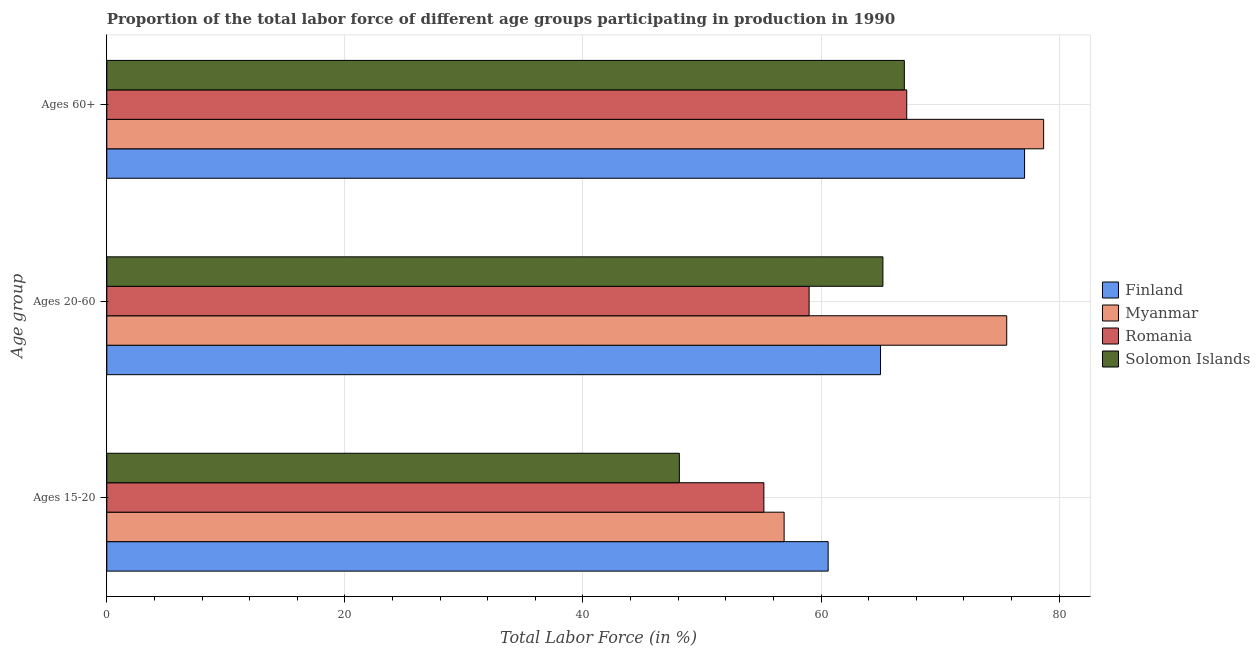How many different coloured bars are there?
Make the answer very short. 4. Are the number of bars on each tick of the Y-axis equal?
Offer a terse response. Yes. What is the label of the 3rd group of bars from the top?
Your response must be concise. Ages 15-20. What is the percentage of labor force within the age group 20-60 in Myanmar?
Provide a short and direct response. 75.6. Across all countries, what is the maximum percentage of labor force above age 60?
Ensure brevity in your answer.  78.7. Across all countries, what is the minimum percentage of labor force within the age group 15-20?
Your answer should be very brief. 48.1. In which country was the percentage of labor force within the age group 20-60 maximum?
Offer a very short reply. Myanmar. In which country was the percentage of labor force above age 60 minimum?
Provide a short and direct response. Solomon Islands. What is the total percentage of labor force within the age group 20-60 in the graph?
Keep it short and to the point. 264.8. What is the difference between the percentage of labor force within the age group 15-20 in Romania and that in Finland?
Your response must be concise. -5.4. What is the difference between the percentage of labor force within the age group 15-20 in Romania and the percentage of labor force within the age group 20-60 in Solomon Islands?
Your response must be concise. -10. What is the average percentage of labor force within the age group 20-60 per country?
Your answer should be compact. 66.2. What is the difference between the percentage of labor force above age 60 and percentage of labor force within the age group 15-20 in Finland?
Ensure brevity in your answer.  16.5. In how many countries, is the percentage of labor force within the age group 20-60 greater than 16 %?
Provide a short and direct response. 4. What is the ratio of the percentage of labor force within the age group 15-20 in Finland to that in Romania?
Make the answer very short. 1.1. Is the percentage of labor force above age 60 in Myanmar less than that in Solomon Islands?
Offer a terse response. No. What is the difference between the highest and the second highest percentage of labor force above age 60?
Provide a short and direct response. 1.6. What is the difference between the highest and the lowest percentage of labor force within the age group 20-60?
Give a very brief answer. 16.6. In how many countries, is the percentage of labor force above age 60 greater than the average percentage of labor force above age 60 taken over all countries?
Provide a short and direct response. 2. What does the 3rd bar from the top in Ages 20-60 represents?
Provide a succinct answer. Myanmar. What does the 2nd bar from the bottom in Ages 20-60 represents?
Your answer should be very brief. Myanmar. How many bars are there?
Ensure brevity in your answer.  12. Are the values on the major ticks of X-axis written in scientific E-notation?
Offer a terse response. No. Does the graph contain grids?
Your answer should be very brief. Yes. Where does the legend appear in the graph?
Keep it short and to the point. Center right. What is the title of the graph?
Your answer should be compact. Proportion of the total labor force of different age groups participating in production in 1990. Does "OECD members" appear as one of the legend labels in the graph?
Keep it short and to the point. No. What is the label or title of the X-axis?
Your response must be concise. Total Labor Force (in %). What is the label or title of the Y-axis?
Your response must be concise. Age group. What is the Total Labor Force (in %) of Finland in Ages 15-20?
Offer a very short reply. 60.6. What is the Total Labor Force (in %) in Myanmar in Ages 15-20?
Your response must be concise. 56.9. What is the Total Labor Force (in %) of Romania in Ages 15-20?
Ensure brevity in your answer.  55.2. What is the Total Labor Force (in %) of Solomon Islands in Ages 15-20?
Your answer should be very brief. 48.1. What is the Total Labor Force (in %) in Finland in Ages 20-60?
Your response must be concise. 65. What is the Total Labor Force (in %) in Myanmar in Ages 20-60?
Ensure brevity in your answer.  75.6. What is the Total Labor Force (in %) of Solomon Islands in Ages 20-60?
Your response must be concise. 65.2. What is the Total Labor Force (in %) of Finland in Ages 60+?
Keep it short and to the point. 77.1. What is the Total Labor Force (in %) in Myanmar in Ages 60+?
Keep it short and to the point. 78.7. What is the Total Labor Force (in %) in Romania in Ages 60+?
Provide a succinct answer. 67.2. Across all Age group, what is the maximum Total Labor Force (in %) in Finland?
Your answer should be very brief. 77.1. Across all Age group, what is the maximum Total Labor Force (in %) of Myanmar?
Offer a terse response. 78.7. Across all Age group, what is the maximum Total Labor Force (in %) in Romania?
Give a very brief answer. 67.2. Across all Age group, what is the minimum Total Labor Force (in %) in Finland?
Your answer should be very brief. 60.6. Across all Age group, what is the minimum Total Labor Force (in %) in Myanmar?
Provide a succinct answer. 56.9. Across all Age group, what is the minimum Total Labor Force (in %) of Romania?
Give a very brief answer. 55.2. Across all Age group, what is the minimum Total Labor Force (in %) in Solomon Islands?
Ensure brevity in your answer.  48.1. What is the total Total Labor Force (in %) of Finland in the graph?
Your answer should be compact. 202.7. What is the total Total Labor Force (in %) of Myanmar in the graph?
Offer a terse response. 211.2. What is the total Total Labor Force (in %) in Romania in the graph?
Ensure brevity in your answer.  181.4. What is the total Total Labor Force (in %) of Solomon Islands in the graph?
Your response must be concise. 180.3. What is the difference between the Total Labor Force (in %) in Finland in Ages 15-20 and that in Ages 20-60?
Your answer should be very brief. -4.4. What is the difference between the Total Labor Force (in %) in Myanmar in Ages 15-20 and that in Ages 20-60?
Keep it short and to the point. -18.7. What is the difference between the Total Labor Force (in %) of Romania in Ages 15-20 and that in Ages 20-60?
Ensure brevity in your answer.  -3.8. What is the difference between the Total Labor Force (in %) of Solomon Islands in Ages 15-20 and that in Ages 20-60?
Provide a short and direct response. -17.1. What is the difference between the Total Labor Force (in %) in Finland in Ages 15-20 and that in Ages 60+?
Ensure brevity in your answer.  -16.5. What is the difference between the Total Labor Force (in %) in Myanmar in Ages 15-20 and that in Ages 60+?
Ensure brevity in your answer.  -21.8. What is the difference between the Total Labor Force (in %) in Solomon Islands in Ages 15-20 and that in Ages 60+?
Keep it short and to the point. -18.9. What is the difference between the Total Labor Force (in %) of Myanmar in Ages 20-60 and that in Ages 60+?
Make the answer very short. -3.1. What is the difference between the Total Labor Force (in %) in Romania in Ages 20-60 and that in Ages 60+?
Give a very brief answer. -8.2. What is the difference between the Total Labor Force (in %) of Finland in Ages 15-20 and the Total Labor Force (in %) of Myanmar in Ages 20-60?
Your response must be concise. -15. What is the difference between the Total Labor Force (in %) in Finland in Ages 15-20 and the Total Labor Force (in %) in Solomon Islands in Ages 20-60?
Your answer should be very brief. -4.6. What is the difference between the Total Labor Force (in %) of Myanmar in Ages 15-20 and the Total Labor Force (in %) of Romania in Ages 20-60?
Your answer should be compact. -2.1. What is the difference between the Total Labor Force (in %) of Myanmar in Ages 15-20 and the Total Labor Force (in %) of Solomon Islands in Ages 20-60?
Provide a short and direct response. -8.3. What is the difference between the Total Labor Force (in %) in Finland in Ages 15-20 and the Total Labor Force (in %) in Myanmar in Ages 60+?
Make the answer very short. -18.1. What is the difference between the Total Labor Force (in %) of Finland in Ages 15-20 and the Total Labor Force (in %) of Romania in Ages 60+?
Provide a succinct answer. -6.6. What is the difference between the Total Labor Force (in %) in Myanmar in Ages 15-20 and the Total Labor Force (in %) in Solomon Islands in Ages 60+?
Offer a terse response. -10.1. What is the difference between the Total Labor Force (in %) of Romania in Ages 15-20 and the Total Labor Force (in %) of Solomon Islands in Ages 60+?
Provide a short and direct response. -11.8. What is the difference between the Total Labor Force (in %) in Finland in Ages 20-60 and the Total Labor Force (in %) in Myanmar in Ages 60+?
Ensure brevity in your answer.  -13.7. What is the difference between the Total Labor Force (in %) of Finland in Ages 20-60 and the Total Labor Force (in %) of Romania in Ages 60+?
Your response must be concise. -2.2. What is the difference between the Total Labor Force (in %) of Finland in Ages 20-60 and the Total Labor Force (in %) of Solomon Islands in Ages 60+?
Offer a terse response. -2. What is the average Total Labor Force (in %) of Finland per Age group?
Offer a terse response. 67.57. What is the average Total Labor Force (in %) in Myanmar per Age group?
Your answer should be very brief. 70.4. What is the average Total Labor Force (in %) in Romania per Age group?
Give a very brief answer. 60.47. What is the average Total Labor Force (in %) of Solomon Islands per Age group?
Offer a very short reply. 60.1. What is the difference between the Total Labor Force (in %) in Finland and Total Labor Force (in %) in Romania in Ages 15-20?
Make the answer very short. 5.4. What is the difference between the Total Labor Force (in %) of Finland and Total Labor Force (in %) of Solomon Islands in Ages 15-20?
Provide a succinct answer. 12.5. What is the difference between the Total Labor Force (in %) of Myanmar and Total Labor Force (in %) of Romania in Ages 15-20?
Give a very brief answer. 1.7. What is the difference between the Total Labor Force (in %) in Finland and Total Labor Force (in %) in Myanmar in Ages 20-60?
Provide a succinct answer. -10.6. What is the difference between the Total Labor Force (in %) in Finland and Total Labor Force (in %) in Solomon Islands in Ages 20-60?
Ensure brevity in your answer.  -0.2. What is the difference between the Total Labor Force (in %) of Finland and Total Labor Force (in %) of Myanmar in Ages 60+?
Give a very brief answer. -1.6. What is the difference between the Total Labor Force (in %) in Finland and Total Labor Force (in %) in Romania in Ages 60+?
Your answer should be very brief. 9.9. What is the difference between the Total Labor Force (in %) of Finland and Total Labor Force (in %) of Solomon Islands in Ages 60+?
Give a very brief answer. 10.1. What is the difference between the Total Labor Force (in %) in Myanmar and Total Labor Force (in %) in Romania in Ages 60+?
Your answer should be very brief. 11.5. What is the difference between the Total Labor Force (in %) in Myanmar and Total Labor Force (in %) in Solomon Islands in Ages 60+?
Ensure brevity in your answer.  11.7. What is the difference between the Total Labor Force (in %) of Romania and Total Labor Force (in %) of Solomon Islands in Ages 60+?
Make the answer very short. 0.2. What is the ratio of the Total Labor Force (in %) of Finland in Ages 15-20 to that in Ages 20-60?
Make the answer very short. 0.93. What is the ratio of the Total Labor Force (in %) in Myanmar in Ages 15-20 to that in Ages 20-60?
Offer a terse response. 0.75. What is the ratio of the Total Labor Force (in %) in Romania in Ages 15-20 to that in Ages 20-60?
Your answer should be very brief. 0.94. What is the ratio of the Total Labor Force (in %) in Solomon Islands in Ages 15-20 to that in Ages 20-60?
Your answer should be very brief. 0.74. What is the ratio of the Total Labor Force (in %) of Finland in Ages 15-20 to that in Ages 60+?
Make the answer very short. 0.79. What is the ratio of the Total Labor Force (in %) in Myanmar in Ages 15-20 to that in Ages 60+?
Provide a short and direct response. 0.72. What is the ratio of the Total Labor Force (in %) of Romania in Ages 15-20 to that in Ages 60+?
Offer a very short reply. 0.82. What is the ratio of the Total Labor Force (in %) of Solomon Islands in Ages 15-20 to that in Ages 60+?
Keep it short and to the point. 0.72. What is the ratio of the Total Labor Force (in %) in Finland in Ages 20-60 to that in Ages 60+?
Provide a short and direct response. 0.84. What is the ratio of the Total Labor Force (in %) in Myanmar in Ages 20-60 to that in Ages 60+?
Provide a succinct answer. 0.96. What is the ratio of the Total Labor Force (in %) of Romania in Ages 20-60 to that in Ages 60+?
Make the answer very short. 0.88. What is the ratio of the Total Labor Force (in %) in Solomon Islands in Ages 20-60 to that in Ages 60+?
Your answer should be compact. 0.97. What is the difference between the highest and the second highest Total Labor Force (in %) in Solomon Islands?
Your answer should be very brief. 1.8. What is the difference between the highest and the lowest Total Labor Force (in %) of Myanmar?
Make the answer very short. 21.8. What is the difference between the highest and the lowest Total Labor Force (in %) of Romania?
Provide a short and direct response. 12. What is the difference between the highest and the lowest Total Labor Force (in %) of Solomon Islands?
Your response must be concise. 18.9. 